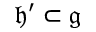<formula> <loc_0><loc_0><loc_500><loc_500>{ \mathfrak { h ^ { \prime } } } \subset { \mathfrak { g } }</formula> 